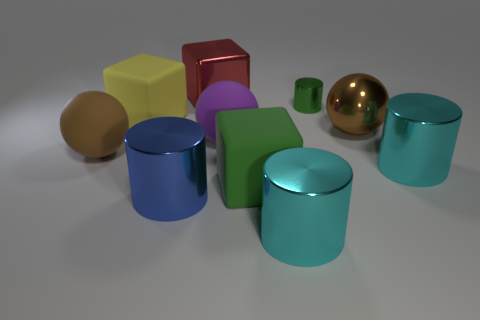Is the size of the brown sphere on the left side of the large yellow rubber object the same as the cyan thing right of the brown metallic sphere?
Offer a terse response. Yes. There is a metallic thing left of the red block; what shape is it?
Provide a succinct answer. Cylinder. The metal sphere has what color?
Your answer should be compact. Brown. There is a brown rubber ball; is its size the same as the object behind the tiny metallic thing?
Give a very brief answer. Yes. What number of shiny objects are either tiny cylinders or purple spheres?
Provide a succinct answer. 1. Is there anything else that has the same material as the yellow cube?
Ensure brevity in your answer.  Yes. Does the small metallic cylinder have the same color as the matte ball right of the big blue cylinder?
Ensure brevity in your answer.  No. What is the shape of the red metal object?
Ensure brevity in your answer.  Cube. What size is the block that is in front of the brown object on the left side of the cyan shiny object to the left of the small shiny cylinder?
Offer a terse response. Large. How many other things are there of the same shape as the yellow rubber object?
Offer a very short reply. 2. 